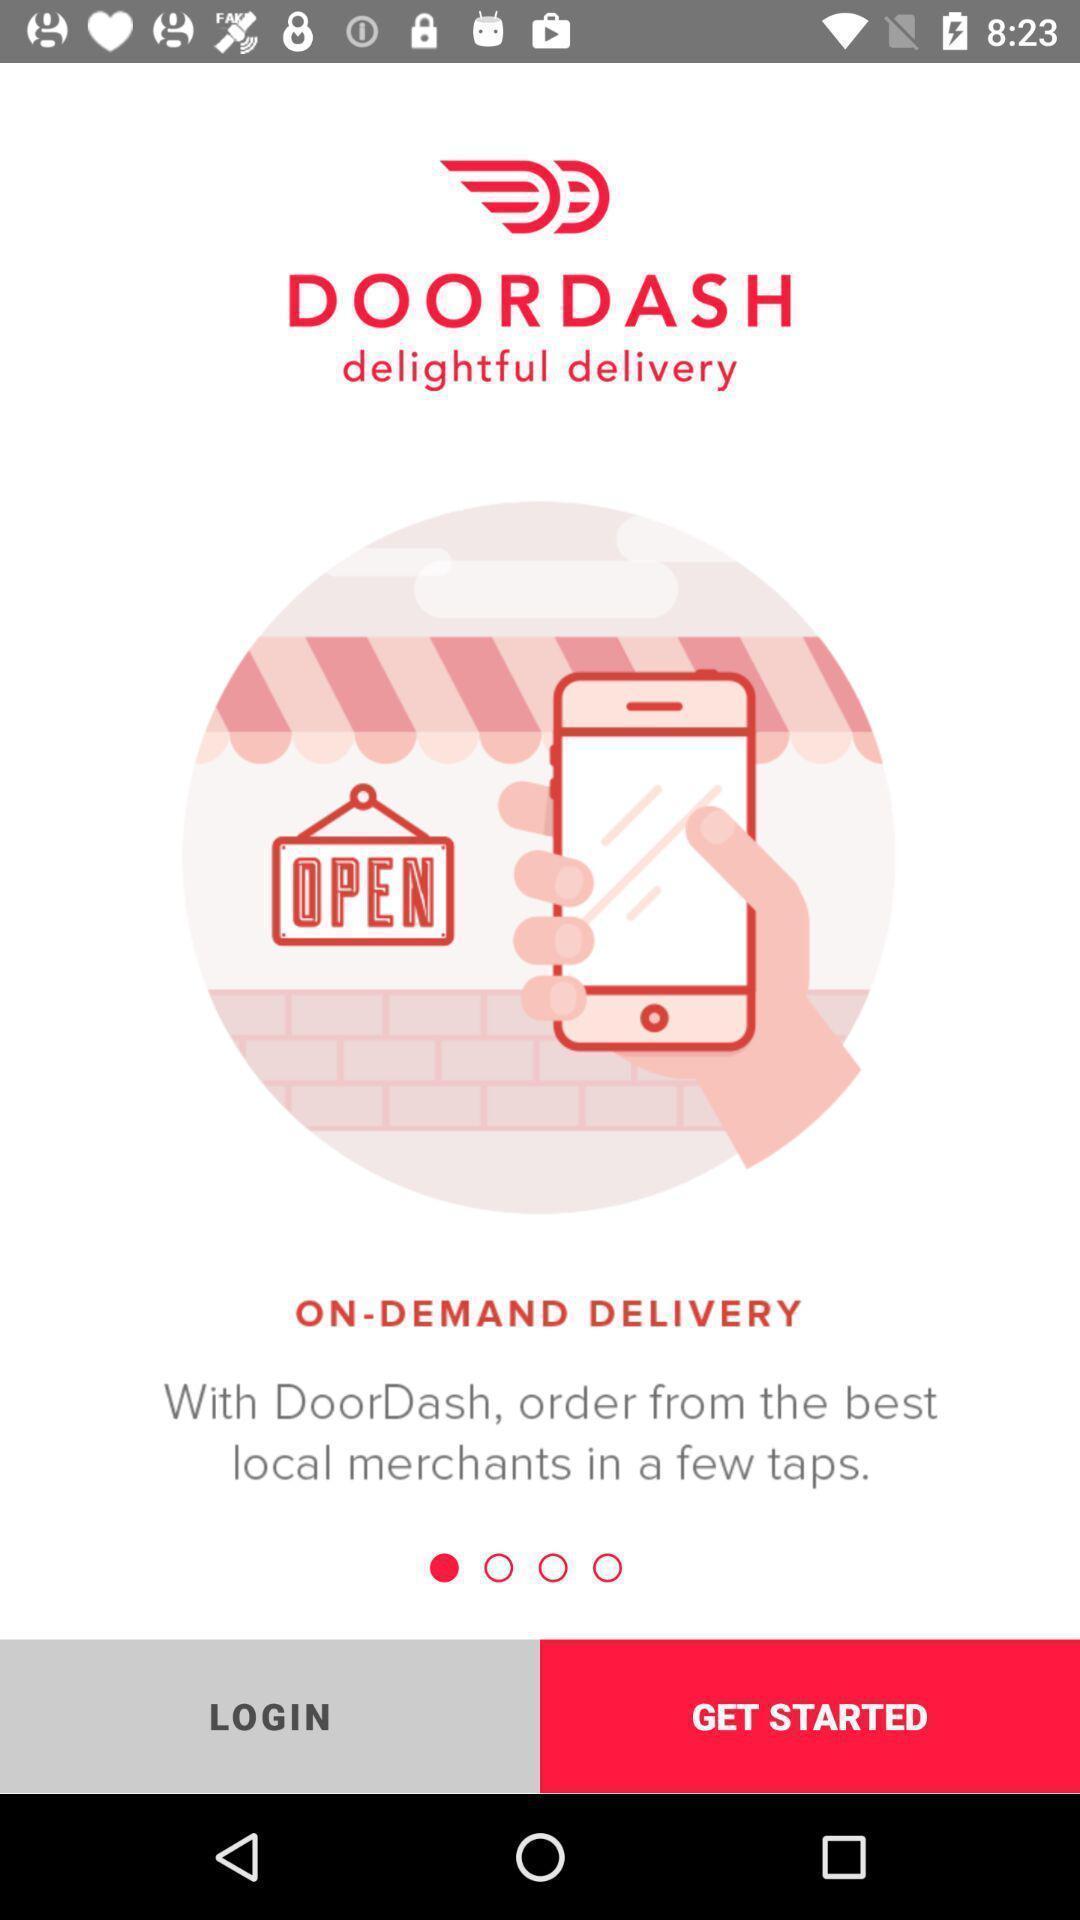What can you discern from this picture? Welcome page. 